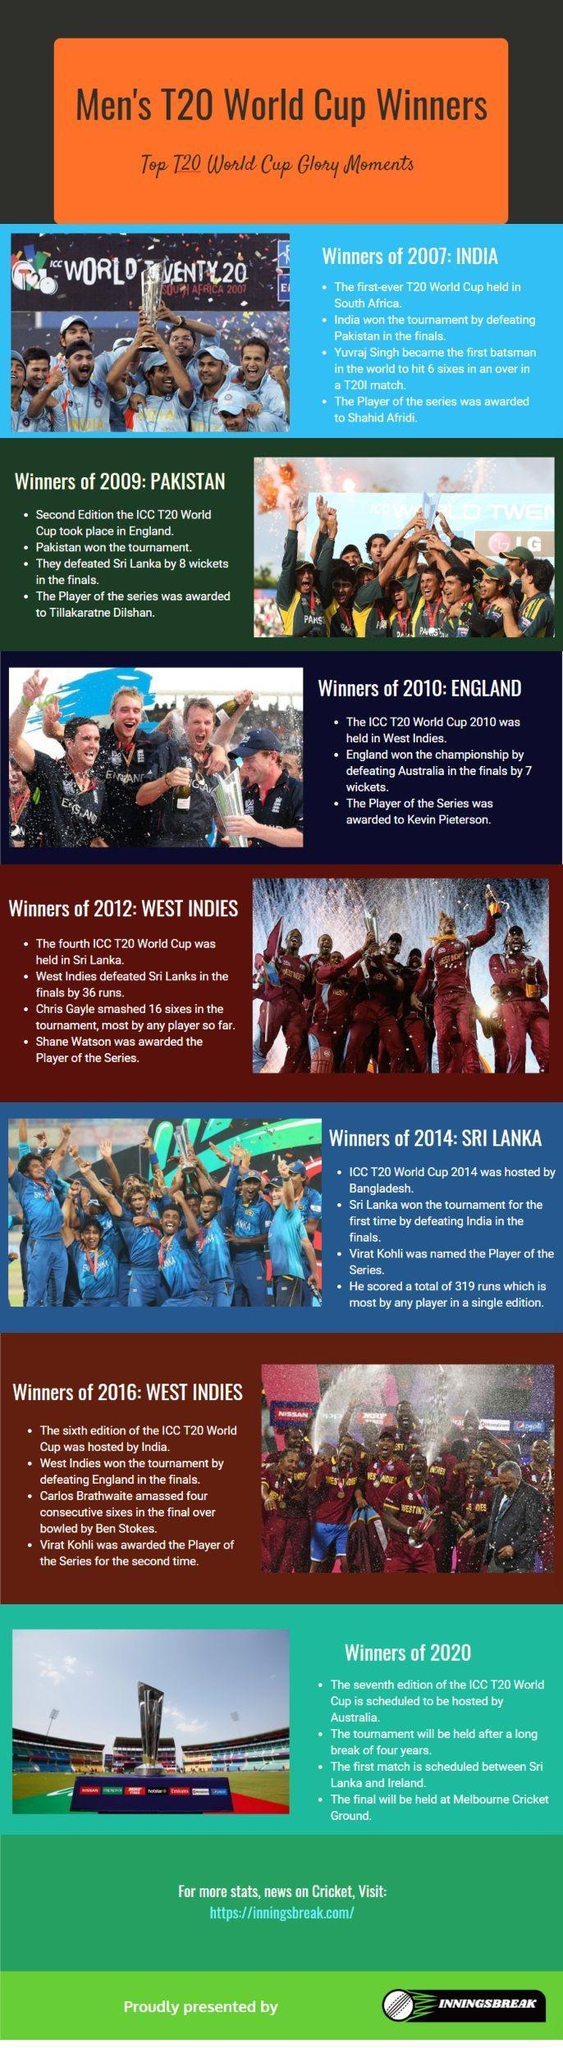How many countries won the T20 world cup championship?
Answer the question with a short phrase. 6 